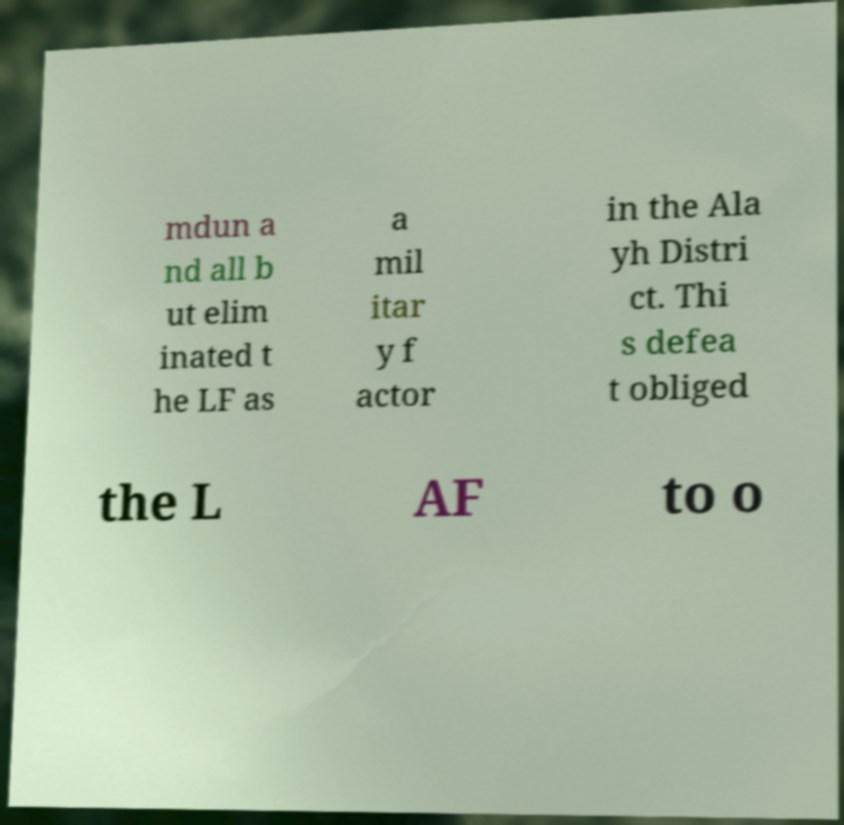Can you accurately transcribe the text from the provided image for me? mdun a nd all b ut elim inated t he LF as a mil itar y f actor in the Ala yh Distri ct. Thi s defea t obliged the L AF to o 